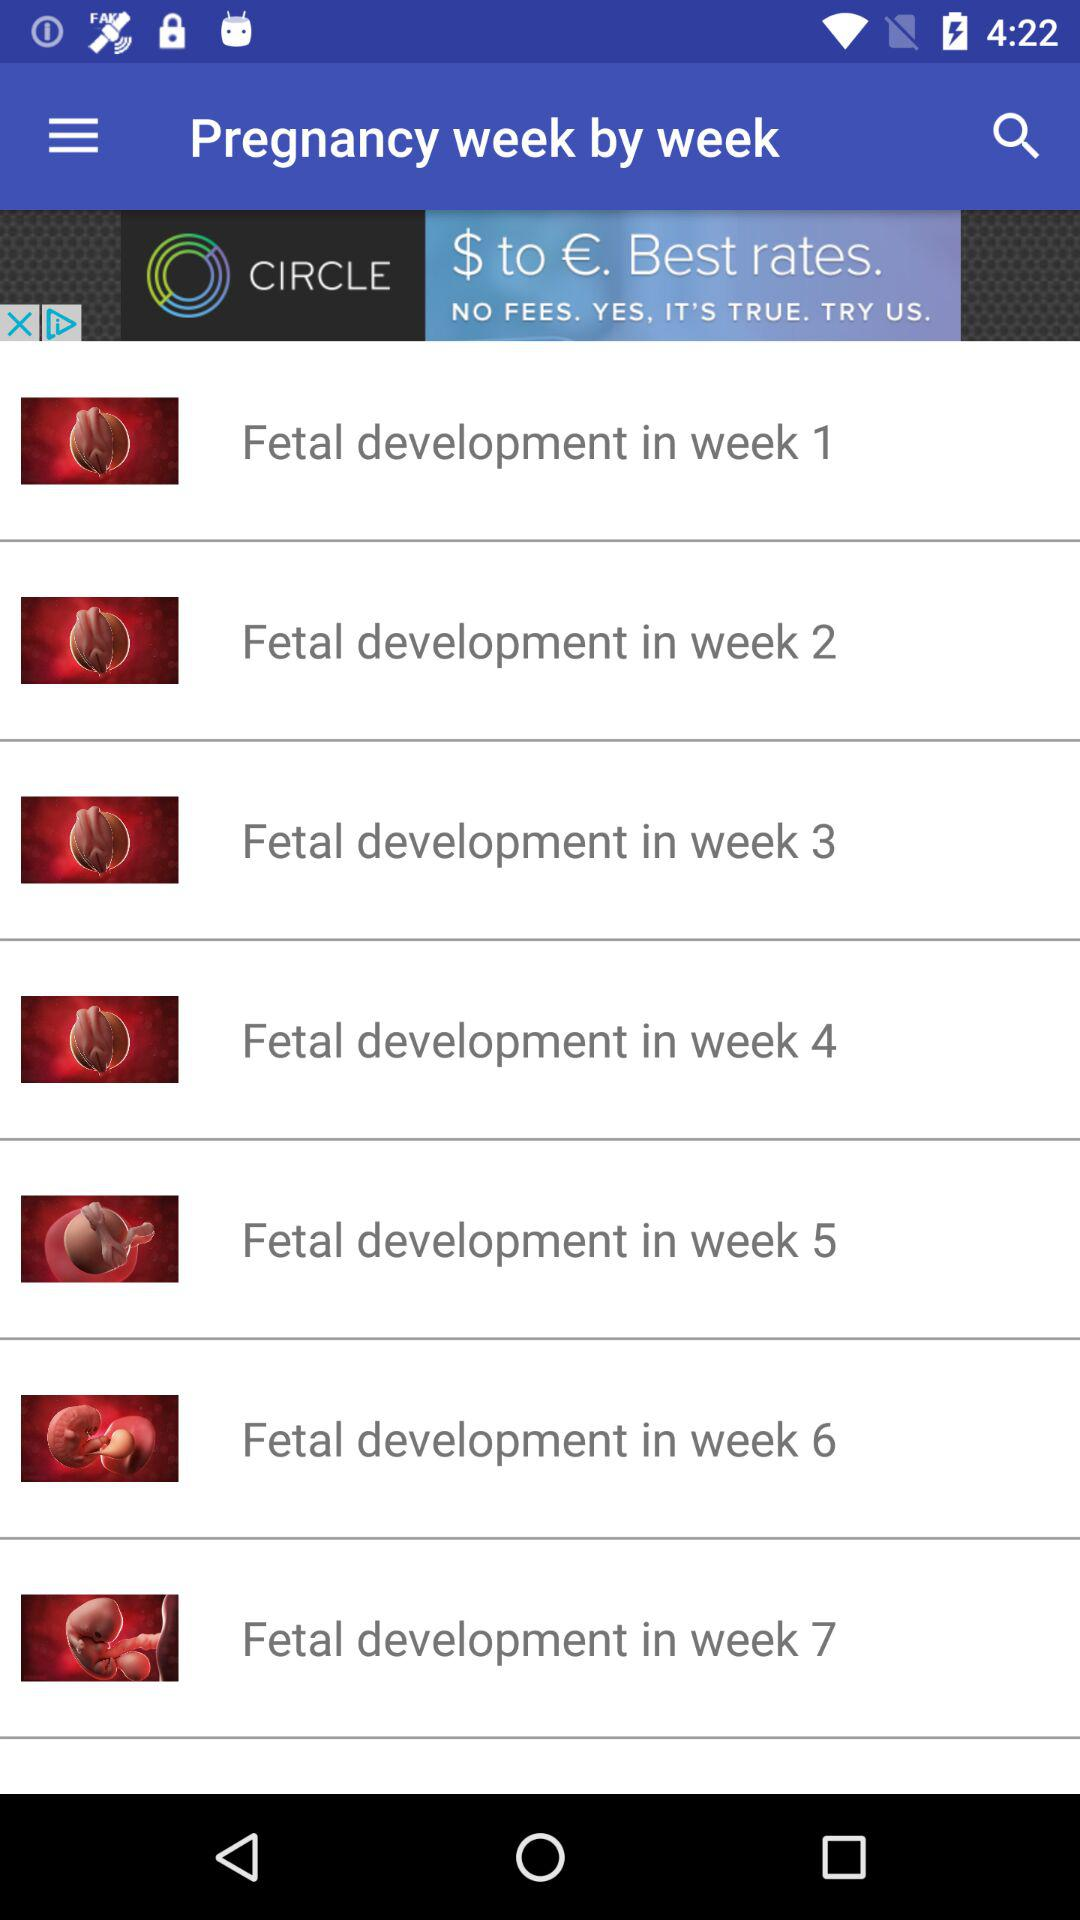How many weeks of pregnancy are covered in this app?
Answer the question using a single word or phrase. 7 